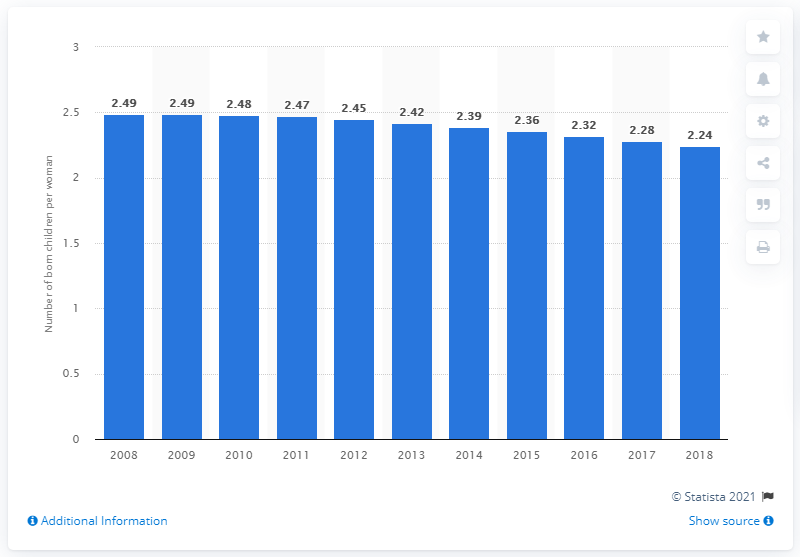List a handful of essential elements in this visual. In 2018, the fertility rate in Libya was 2.24. 